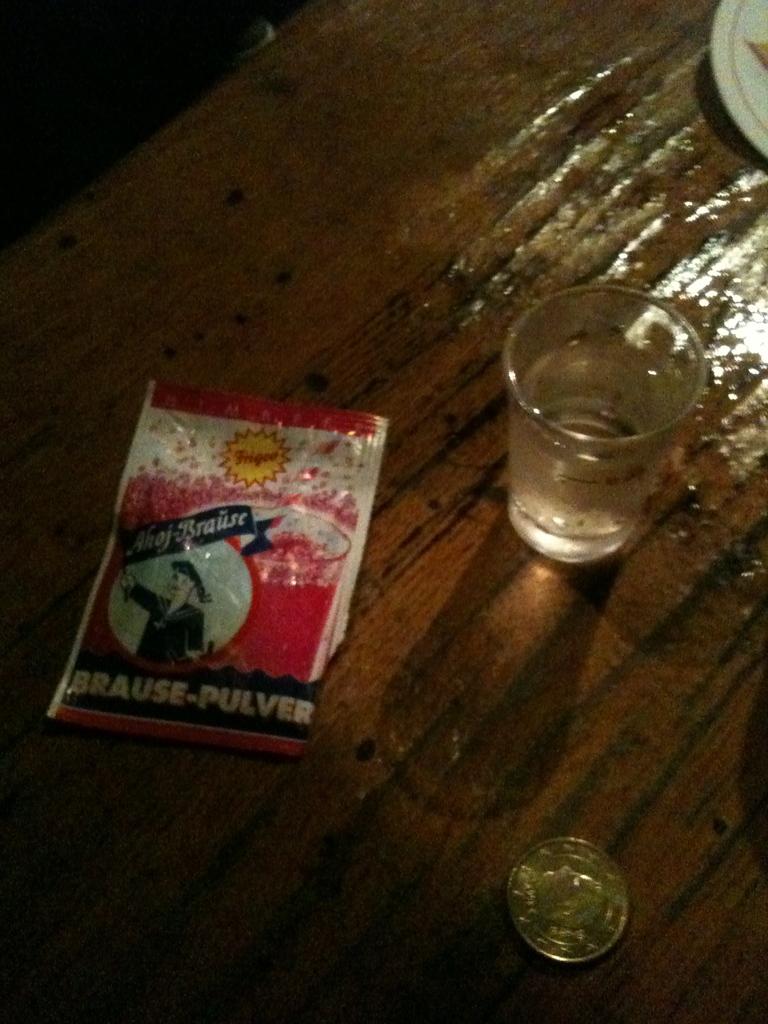What brand is listed on the bottom of the package?
Your answer should be compact. Brause-pulver. 